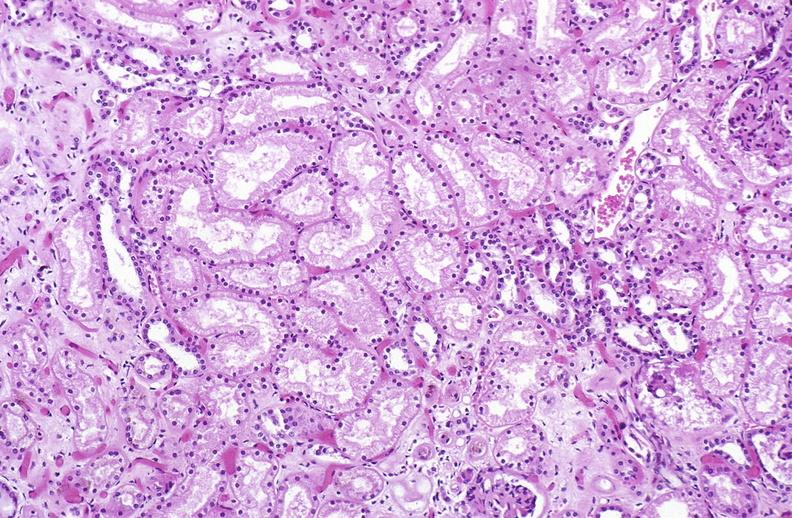where is this?
Answer the question using a single word or phrase. Urinary 